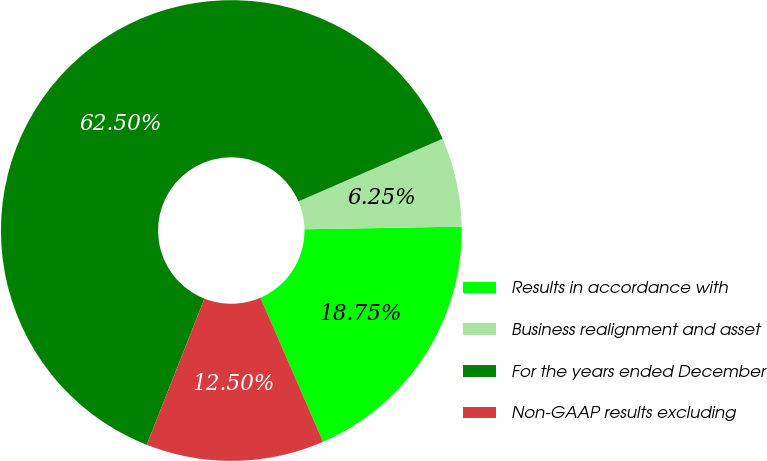Convert chart to OTSL. <chart><loc_0><loc_0><loc_500><loc_500><pie_chart><fcel>Results in accordance with<fcel>Business realignment and asset<fcel>For the years ended December<fcel>Non-GAAP results excluding<nl><fcel>18.75%<fcel>6.25%<fcel>62.5%<fcel>12.5%<nl></chart> 